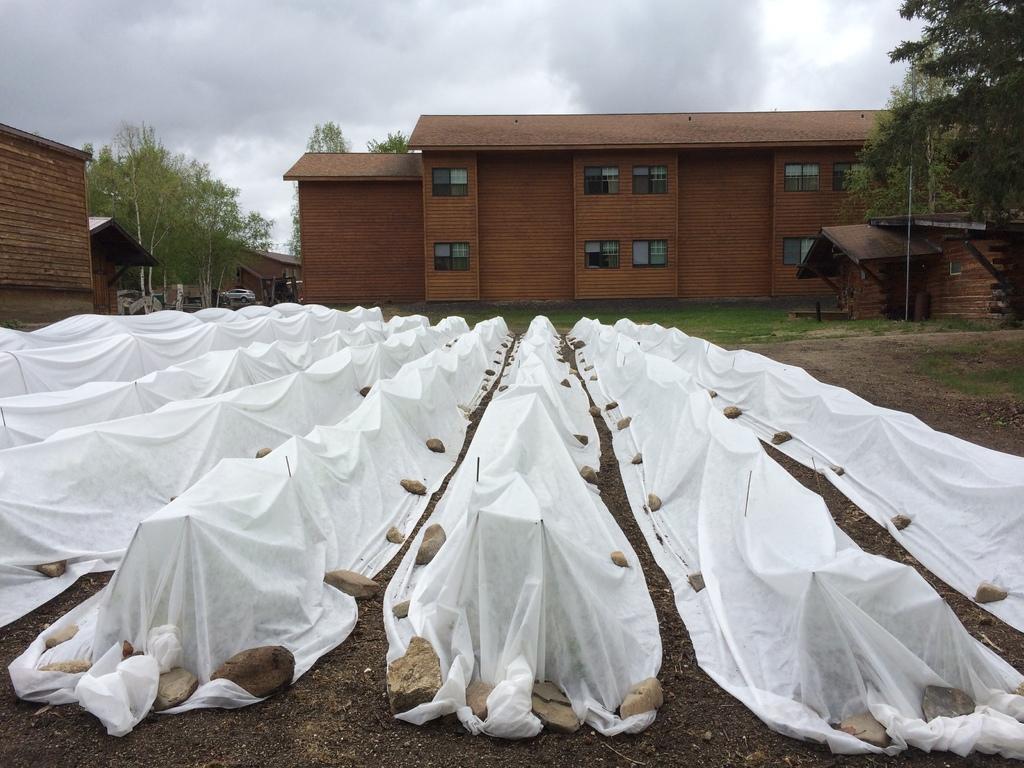In one or two sentences, can you explain what this image depicts? In the picture we can see a ground surface on it, we can see some white color clothes which are placed on the sticks and some stones are placed near it and in the background, we can see a grass surface and behind it, we can see a building which is brown in color and some windows to it with glasses and beside the building we can see some trees and some houses and vehicles and in the background we can see a sky with clouds. 